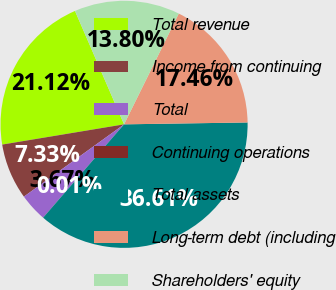Convert chart to OTSL. <chart><loc_0><loc_0><loc_500><loc_500><pie_chart><fcel>Total revenue<fcel>Income from continuing<fcel>Total<fcel>Continuing operations<fcel>Total assets<fcel>Long-term debt (including<fcel>Shareholders' equity<nl><fcel>21.12%<fcel>7.33%<fcel>3.67%<fcel>0.01%<fcel>36.61%<fcel>17.46%<fcel>13.8%<nl></chart> 